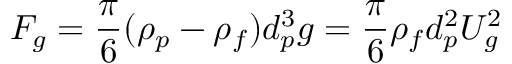<formula> <loc_0><loc_0><loc_500><loc_500>F _ { g } = \frac { \pi } { 6 } ( \rho _ { p } - \rho _ { f } ) d _ { p } ^ { 3 } g = \frac { \pi } { 6 } \rho _ { f } d _ { p } ^ { 2 } U _ { g } ^ { 2 }</formula> 